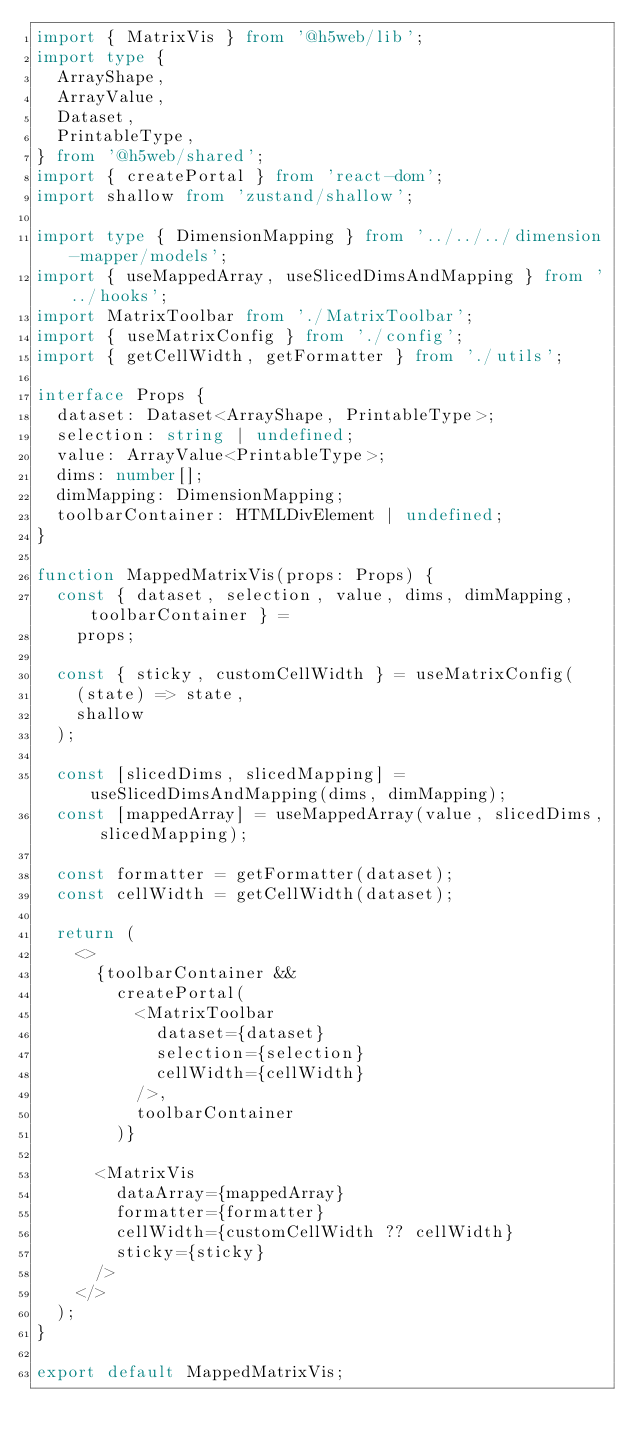Convert code to text. <code><loc_0><loc_0><loc_500><loc_500><_TypeScript_>import { MatrixVis } from '@h5web/lib';
import type {
  ArrayShape,
  ArrayValue,
  Dataset,
  PrintableType,
} from '@h5web/shared';
import { createPortal } from 'react-dom';
import shallow from 'zustand/shallow';

import type { DimensionMapping } from '../../../dimension-mapper/models';
import { useMappedArray, useSlicedDimsAndMapping } from '../hooks';
import MatrixToolbar from './MatrixToolbar';
import { useMatrixConfig } from './config';
import { getCellWidth, getFormatter } from './utils';

interface Props {
  dataset: Dataset<ArrayShape, PrintableType>;
  selection: string | undefined;
  value: ArrayValue<PrintableType>;
  dims: number[];
  dimMapping: DimensionMapping;
  toolbarContainer: HTMLDivElement | undefined;
}

function MappedMatrixVis(props: Props) {
  const { dataset, selection, value, dims, dimMapping, toolbarContainer } =
    props;

  const { sticky, customCellWidth } = useMatrixConfig(
    (state) => state,
    shallow
  );

  const [slicedDims, slicedMapping] = useSlicedDimsAndMapping(dims, dimMapping);
  const [mappedArray] = useMappedArray(value, slicedDims, slicedMapping);

  const formatter = getFormatter(dataset);
  const cellWidth = getCellWidth(dataset);

  return (
    <>
      {toolbarContainer &&
        createPortal(
          <MatrixToolbar
            dataset={dataset}
            selection={selection}
            cellWidth={cellWidth}
          />,
          toolbarContainer
        )}

      <MatrixVis
        dataArray={mappedArray}
        formatter={formatter}
        cellWidth={customCellWidth ?? cellWidth}
        sticky={sticky}
      />
    </>
  );
}

export default MappedMatrixVis;
</code> 